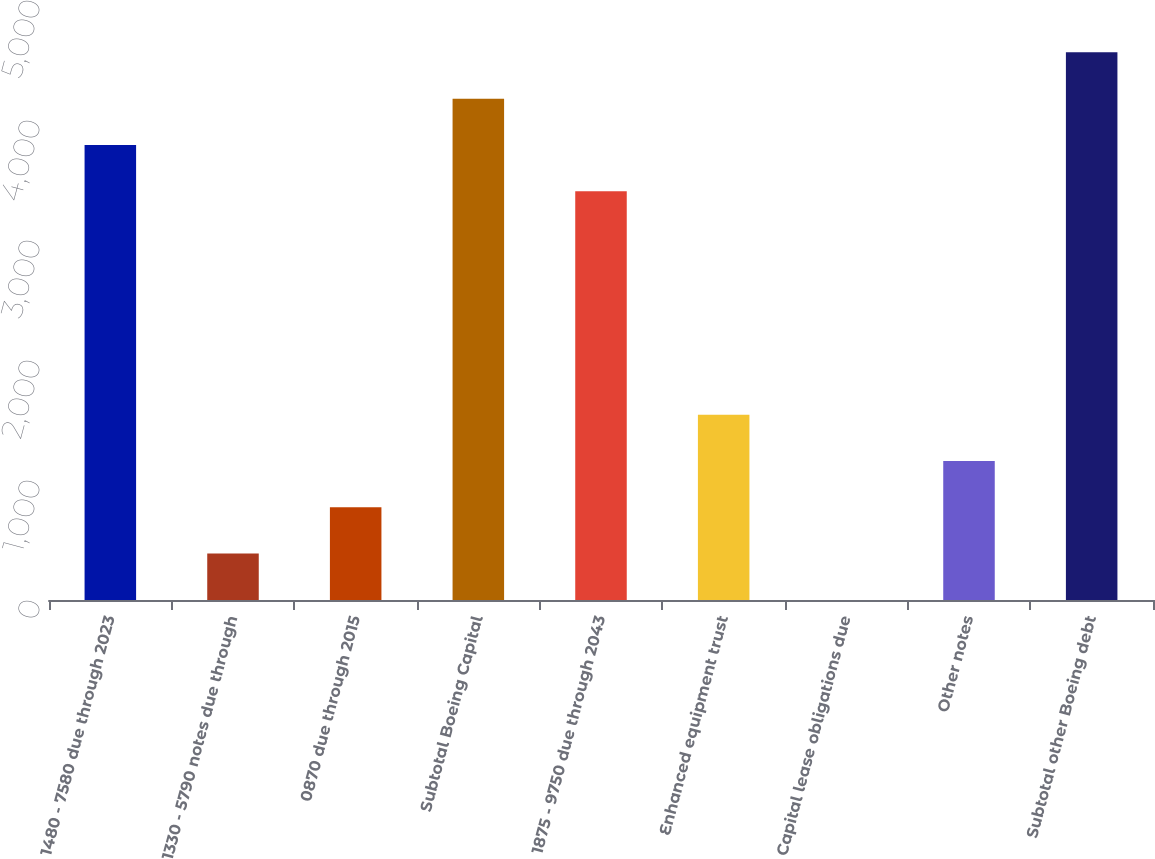Convert chart to OTSL. <chart><loc_0><loc_0><loc_500><loc_500><bar_chart><fcel>1480 - 7580 due through 2023<fcel>1330 - 5790 notes due through<fcel>0870 due through 2015<fcel>Subtotal Boeing Capital<fcel>1875 - 9750 due through 2043<fcel>Enhanced equipment trust<fcel>Capital lease obligations due<fcel>Other notes<fcel>Subtotal other Boeing debt<nl><fcel>3791.9<fcel>386.9<fcel>772.8<fcel>4177.8<fcel>3406<fcel>1544.6<fcel>1<fcel>1158.7<fcel>4563.7<nl></chart> 